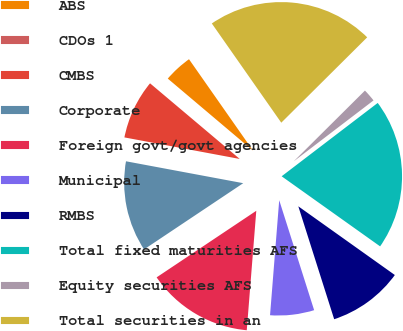Convert chart to OTSL. <chart><loc_0><loc_0><loc_500><loc_500><pie_chart><fcel>ABS<fcel>CDOs 1<fcel>CMBS<fcel>Corporate<fcel>Foreign govt/govt agencies<fcel>Municipal<fcel>RMBS<fcel>Total fixed maturities AFS<fcel>Equity securities AFS<fcel>Total securities in an<nl><fcel>4.11%<fcel>0.02%<fcel>8.21%<fcel>12.31%<fcel>14.36%<fcel>6.16%<fcel>10.26%<fcel>20.22%<fcel>2.07%<fcel>22.27%<nl></chart> 